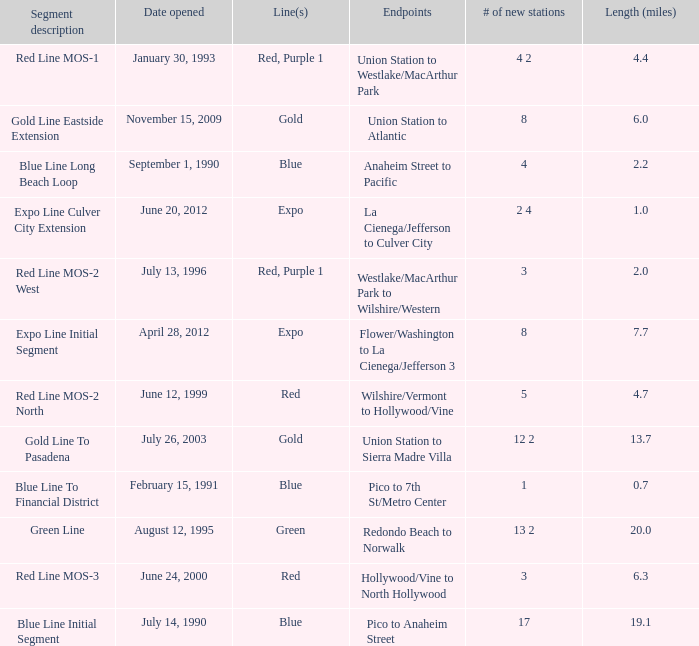What is the length  (miles) when pico to 7th st/metro center are the endpoints? 0.7. 